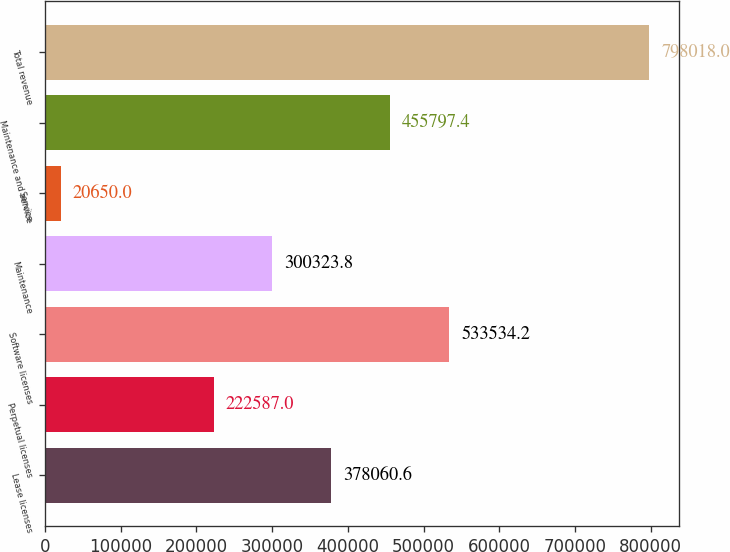Convert chart. <chart><loc_0><loc_0><loc_500><loc_500><bar_chart><fcel>Lease licenses<fcel>Perpetual licenses<fcel>Software licenses<fcel>Maintenance<fcel>Service<fcel>Maintenance and service<fcel>Total revenue<nl><fcel>378061<fcel>222587<fcel>533534<fcel>300324<fcel>20650<fcel>455797<fcel>798018<nl></chart> 